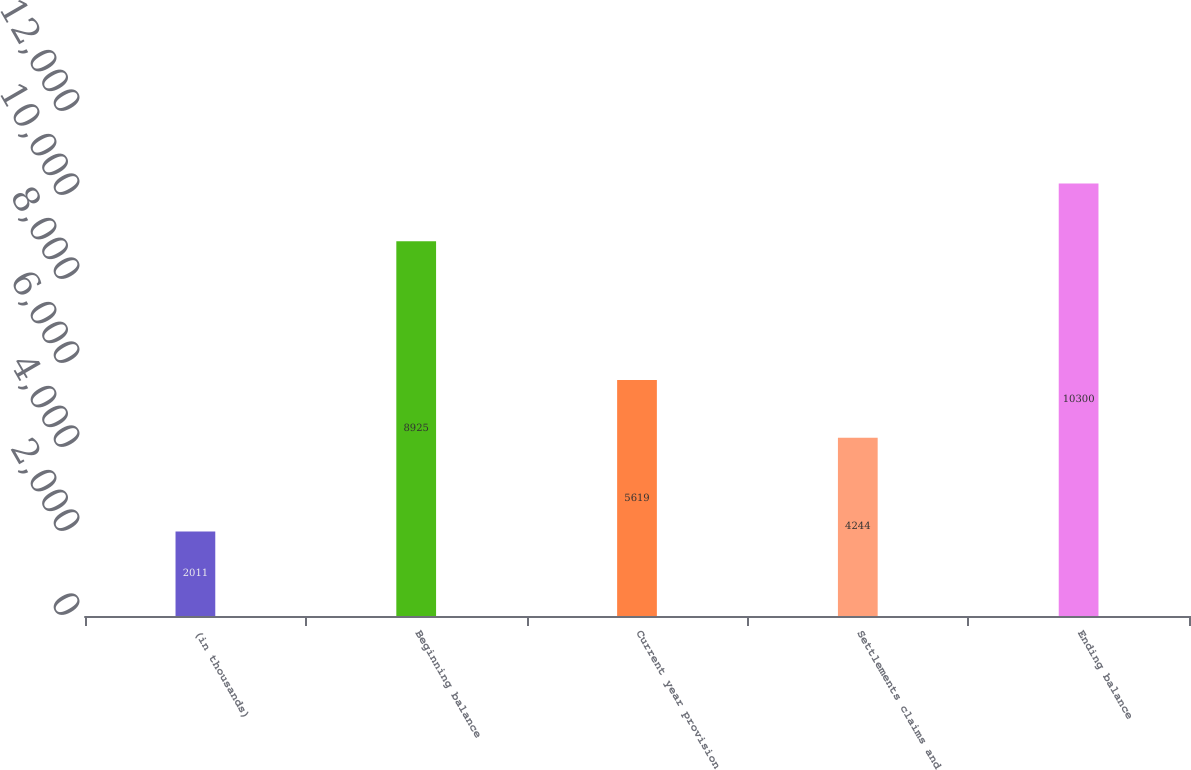Convert chart to OTSL. <chart><loc_0><loc_0><loc_500><loc_500><bar_chart><fcel>(in thousands)<fcel>Beginning balance<fcel>Current year provision<fcel>Settlements claims and<fcel>Ending balance<nl><fcel>2011<fcel>8925<fcel>5619<fcel>4244<fcel>10300<nl></chart> 